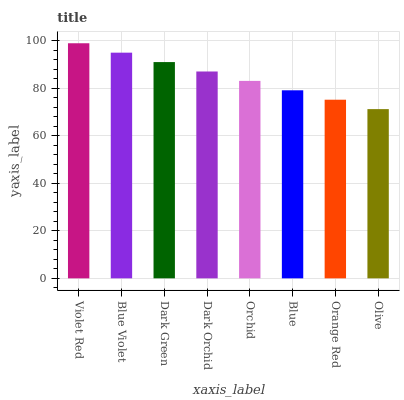Is Blue Violet the minimum?
Answer yes or no. No. Is Blue Violet the maximum?
Answer yes or no. No. Is Violet Red greater than Blue Violet?
Answer yes or no. Yes. Is Blue Violet less than Violet Red?
Answer yes or no. Yes. Is Blue Violet greater than Violet Red?
Answer yes or no. No. Is Violet Red less than Blue Violet?
Answer yes or no. No. Is Dark Orchid the high median?
Answer yes or no. Yes. Is Orchid the low median?
Answer yes or no. Yes. Is Orchid the high median?
Answer yes or no. No. Is Dark Orchid the low median?
Answer yes or no. No. 